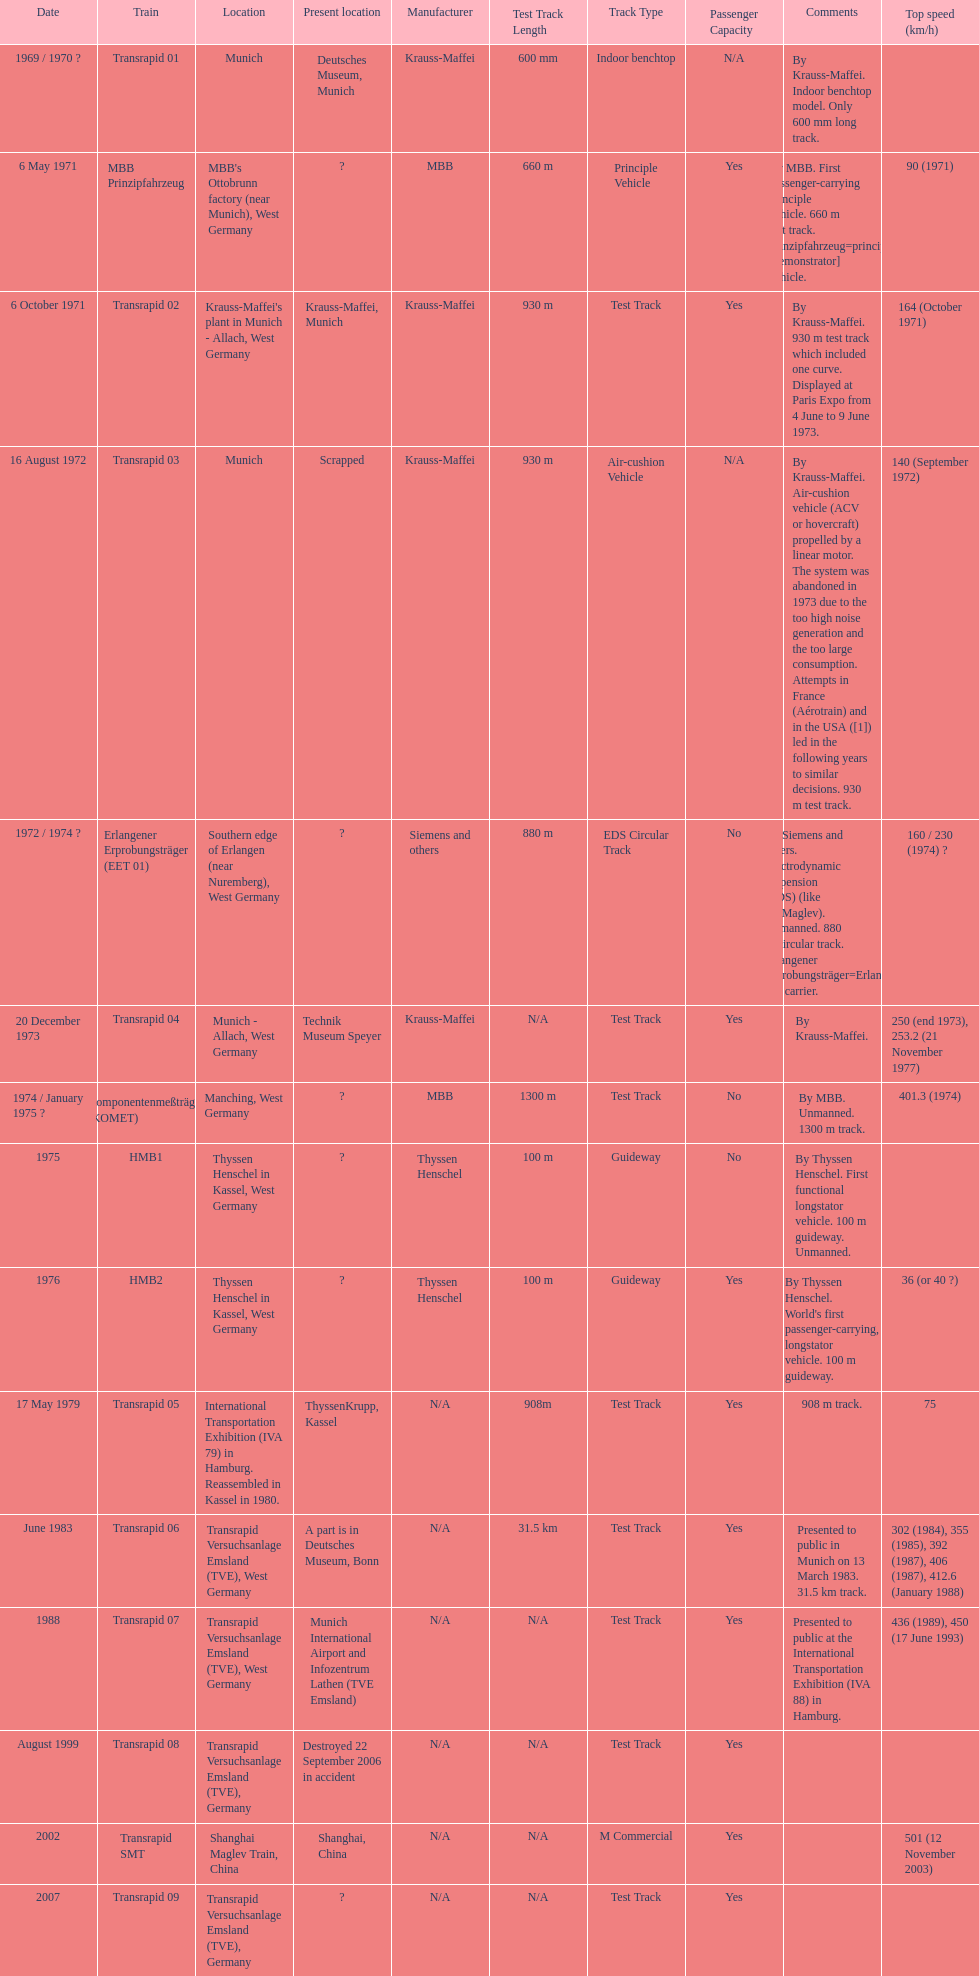Which train has the lowest maximum speed? HMB2. 